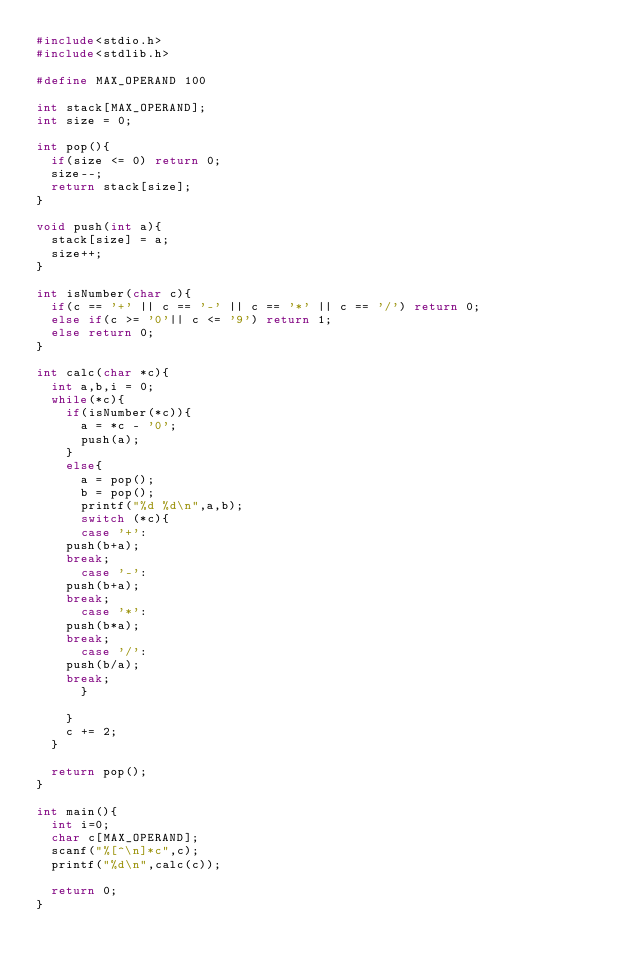<code> <loc_0><loc_0><loc_500><loc_500><_C_>#include<stdio.h>
#include<stdlib.h>

#define MAX_OPERAND 100

int stack[MAX_OPERAND];
int size = 0;

int pop(){
  if(size <= 0) return 0;
  size--;
  return stack[size];
}

void push(int a){
  stack[size] = a;
  size++;
}

int isNumber(char c){
  if(c == '+' || c == '-' || c == '*' || c == '/') return 0;
  else if(c >= '0'|| c <= '9') return 1;
  else return 0;
}

int calc(char *c){
  int a,b,i = 0;
  while(*c){
    if(isNumber(*c)){
      a = *c - '0';
      push(a);
    }
    else{
      a = pop();
      b = pop();
      printf("%d %d\n",a,b);
      switch (*c){
      case '+':
	push(b+a);
	break;
      case '-':
	push(b+a);
	break;
      case '*':
	push(b*a);
	break;
      case '/':
	push(b/a);
	break;
      }

    }
    c += 2;
  }

  return pop();
}

int main(){
  int i=0;
  char c[MAX_OPERAND];
  scanf("%[^\n]*c",c);
  printf("%d\n",calc(c));
  
  return 0;
}

</code> 